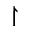Convert formula to latex. <formula><loc_0><loc_0><loc_500><loc_500>\upharpoonright</formula> 